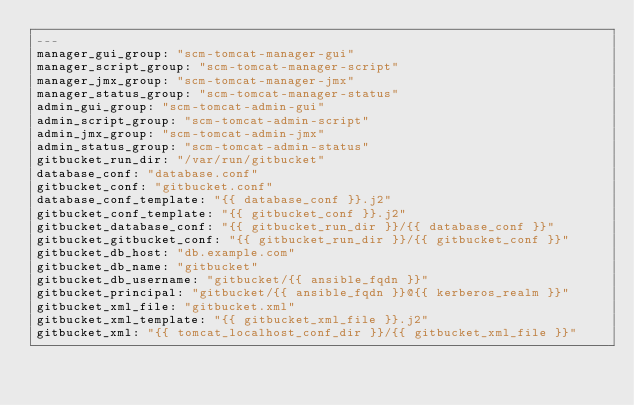<code> <loc_0><loc_0><loc_500><loc_500><_YAML_>---
manager_gui_group: "scm-tomcat-manager-gui"
manager_script_group: "scm-tomcat-manager-script"
manager_jmx_group: "scm-tomcat-manager-jmx"
manager_status_group: "scm-tomcat-manager-status"
admin_gui_group: "scm-tomcat-admin-gui"
admin_script_group: "scm-tomcat-admin-script"
admin_jmx_group: "scm-tomcat-admin-jmx"
admin_status_group: "scm-tomcat-admin-status"
gitbucket_run_dir: "/var/run/gitbucket"
database_conf: "database.conf"
gitbucket_conf: "gitbucket.conf"
database_conf_template: "{{ database_conf }}.j2"
gitbucket_conf_template: "{{ gitbucket_conf }}.j2"
gitbucket_database_conf: "{{ gitbucket_run_dir }}/{{ database_conf }}"
gitbucket_gitbucket_conf: "{{ gitbucket_run_dir }}/{{ gitbucket_conf }}"
gitbucket_db_host: "db.example.com"
gitbucket_db_name: "gitbucket"
gitbucket_db_username: "gitbucket/{{ ansible_fqdn }}"
gitbucket_principal: "gitbucket/{{ ansible_fqdn }}@{{ kerberos_realm }}"
gitbucket_xml_file: "gitbucket.xml"
gitbucket_xml_template: "{{ gitbucket_xml_file }}.j2"
gitbucket_xml: "{{ tomcat_localhost_conf_dir }}/{{ gitbucket_xml_file }}"

</code> 